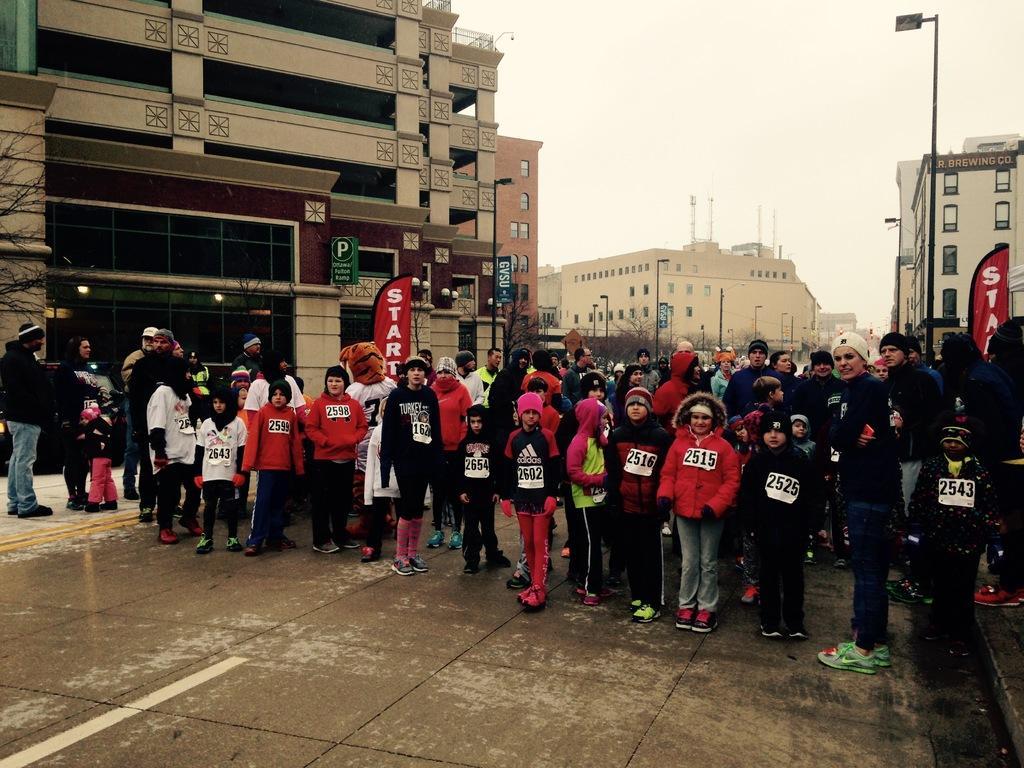In one or two sentences, can you explain what this image depicts? In the foreground of the picture I can see a group of people standing on the road. In the background, I can see the buildings, light poles and trees. There are clouds in the sky. 